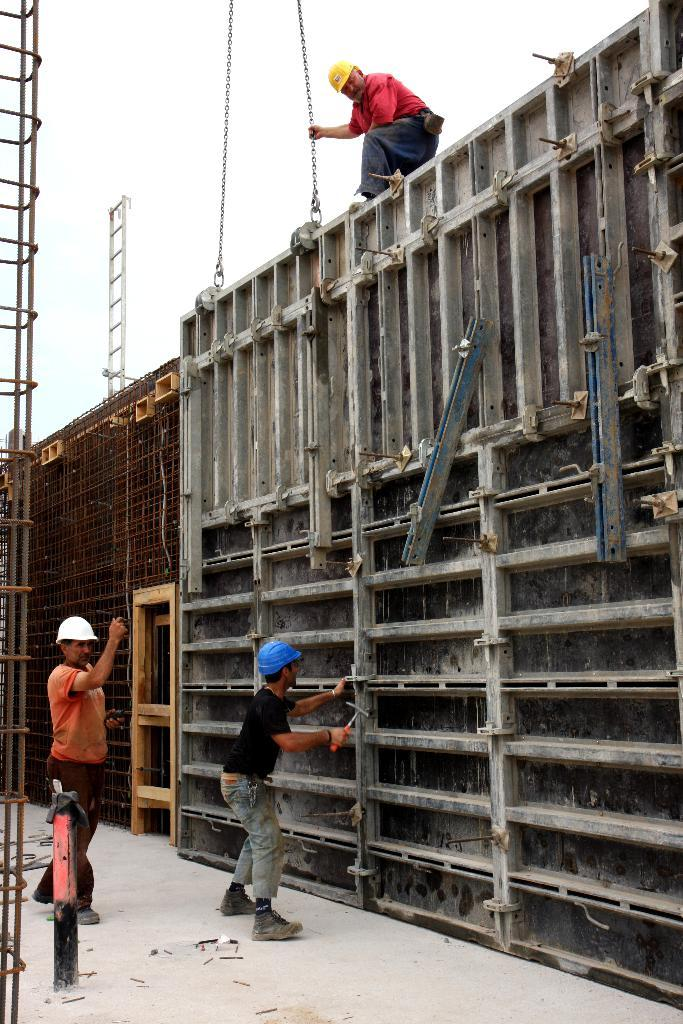Who is present in the image? There are people in the image. What are the people doing in the image? The people are building a wall. Can you describe the wall that is being built? The wall has shelves. What is the income of the people building the wall in the image? The income of the people building the wall cannot be determined from the image. 